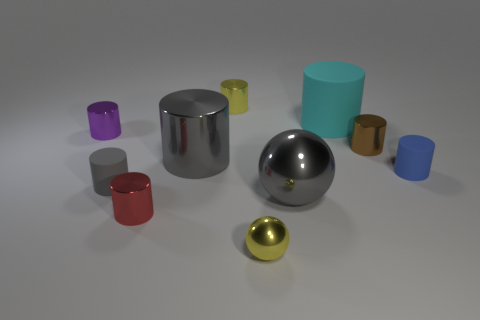There is a small rubber thing to the right of the large cyan rubber cylinder; is it the same color as the matte object that is to the left of the cyan rubber object?
Provide a short and direct response. No. Is the number of brown objects that are left of the tiny yellow metal cylinder less than the number of small purple cylinders that are in front of the small red cylinder?
Your answer should be compact. No. Is there anything else that is the same shape as the tiny blue thing?
Your answer should be very brief. Yes. There is a big metallic thing that is the same shape as the tiny red shiny thing; what color is it?
Keep it short and to the point. Gray. There is a large cyan thing; does it have the same shape as the small yellow metal object behind the tiny gray cylinder?
Ensure brevity in your answer.  Yes. How many things are gray things that are right of the small shiny ball or gray things to the left of the small yellow metallic cylinder?
Make the answer very short. 3. What is the material of the small blue cylinder?
Provide a succinct answer. Rubber. How many other things are there of the same size as the blue rubber cylinder?
Keep it short and to the point. 6. There is a matte cylinder that is behind the blue rubber thing; what is its size?
Ensure brevity in your answer.  Large. What material is the big cylinder that is on the left side of the gray object that is in front of the small matte cylinder that is to the left of the tiny yellow shiny ball?
Provide a succinct answer. Metal. 